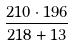Convert formula to latex. <formula><loc_0><loc_0><loc_500><loc_500>\frac { 2 1 0 \cdot 1 9 6 } { 2 1 8 + 1 3 }</formula> 